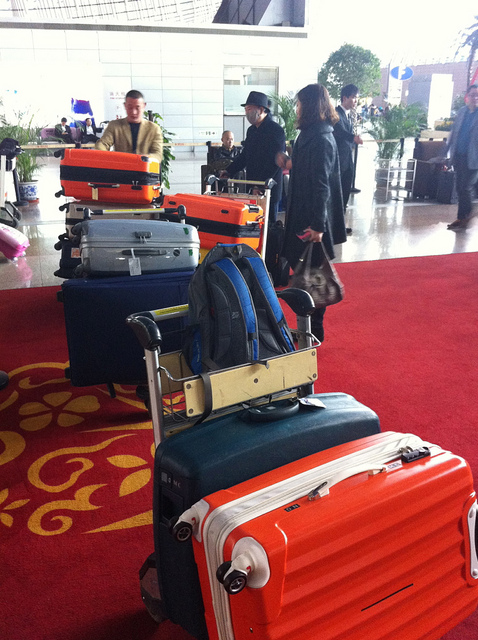Can you tell what the weather might be outside based on the luggage? The luggage itself doesn't provide clear indicators of weather conditions. There are no items like umbrellas or winter gear that would suggest rain or cold weather, so it might be fair to assume the weather is clear or moderate. 